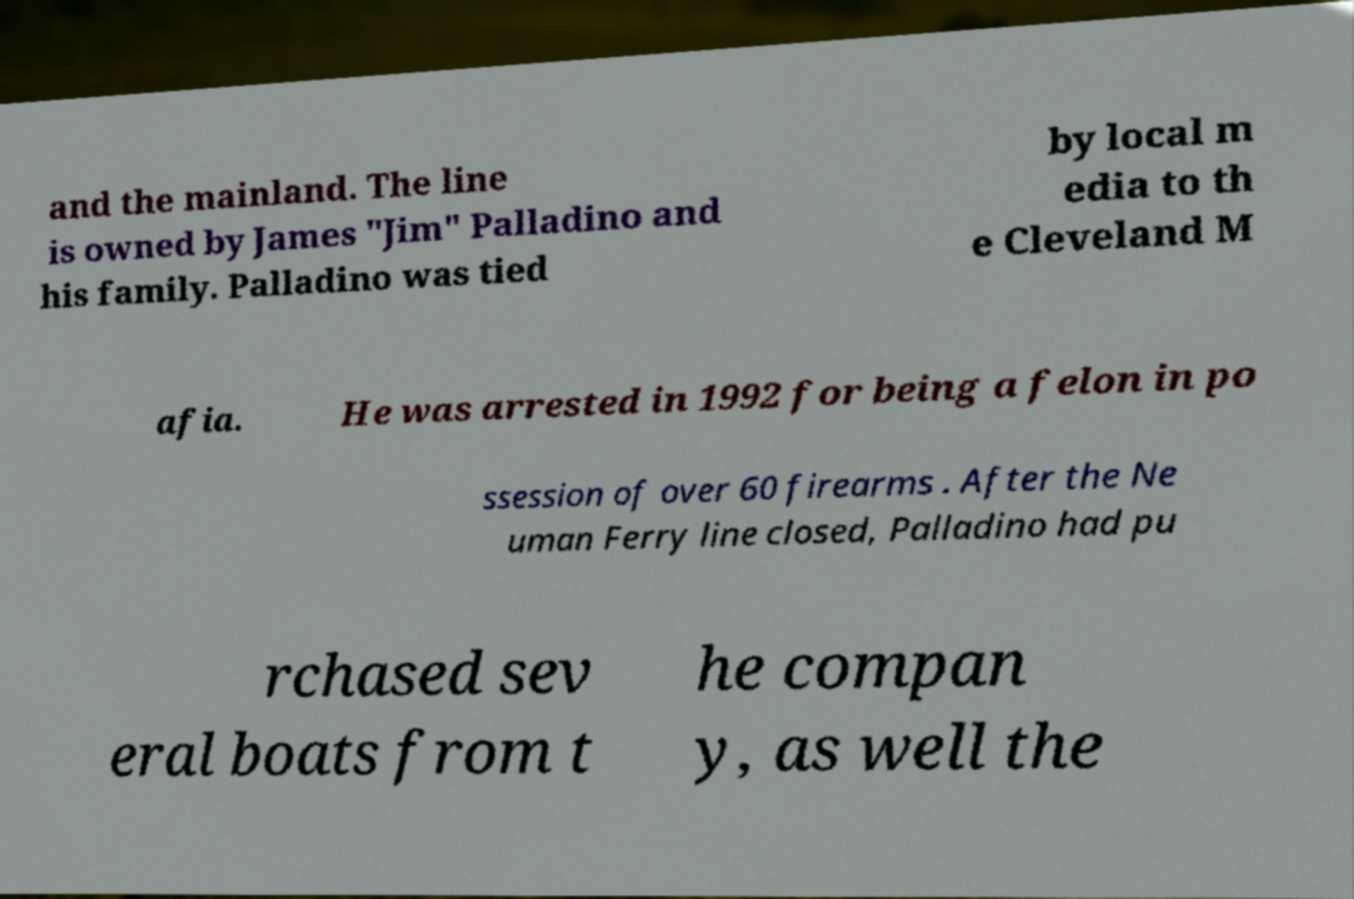Please read and relay the text visible in this image. What does it say? and the mainland. The line is owned by James "Jim" Palladino and his family. Palladino was tied by local m edia to th e Cleveland M afia. He was arrested in 1992 for being a felon in po ssession of over 60 firearms . After the Ne uman Ferry line closed, Palladino had pu rchased sev eral boats from t he compan y, as well the 